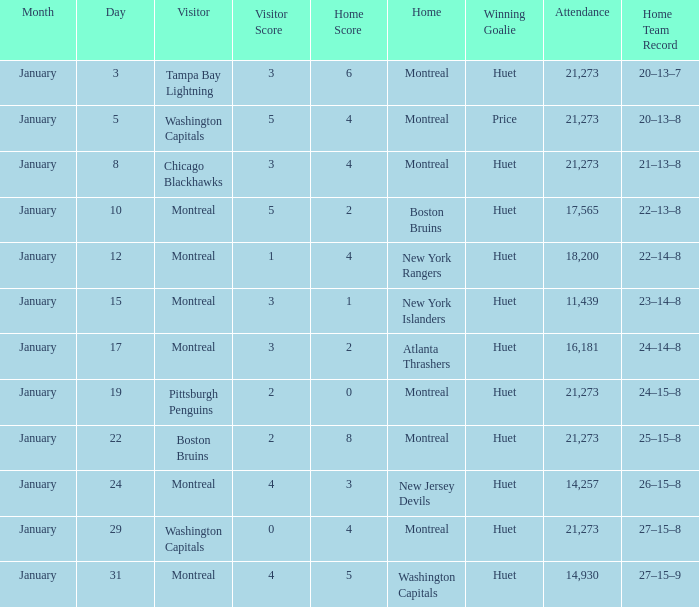What was the date of the game that had a score of 3 – 1? January 15. 